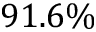<formula> <loc_0><loc_0><loc_500><loc_500>9 1 . 6 \%</formula> 